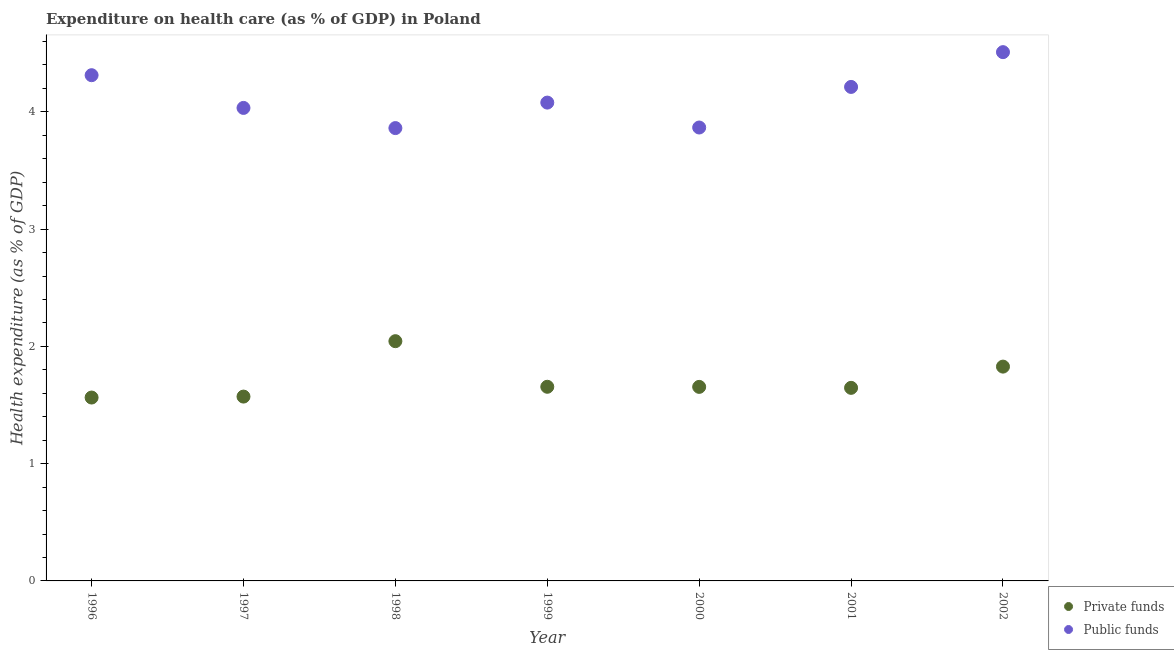Is the number of dotlines equal to the number of legend labels?
Offer a very short reply. Yes. What is the amount of private funds spent in healthcare in 2002?
Offer a terse response. 1.83. Across all years, what is the maximum amount of private funds spent in healthcare?
Provide a short and direct response. 2.04. Across all years, what is the minimum amount of private funds spent in healthcare?
Ensure brevity in your answer.  1.56. In which year was the amount of public funds spent in healthcare maximum?
Make the answer very short. 2002. In which year was the amount of private funds spent in healthcare minimum?
Give a very brief answer. 1996. What is the total amount of private funds spent in healthcare in the graph?
Provide a succinct answer. 11.96. What is the difference between the amount of public funds spent in healthcare in 1997 and that in 2001?
Provide a succinct answer. -0.18. What is the difference between the amount of private funds spent in healthcare in 1997 and the amount of public funds spent in healthcare in 1998?
Offer a very short reply. -2.29. What is the average amount of private funds spent in healthcare per year?
Your answer should be compact. 1.71. In the year 1999, what is the difference between the amount of private funds spent in healthcare and amount of public funds spent in healthcare?
Your answer should be compact. -2.42. In how many years, is the amount of private funds spent in healthcare greater than 1.4 %?
Offer a terse response. 7. What is the ratio of the amount of private funds spent in healthcare in 1997 to that in 2000?
Keep it short and to the point. 0.95. Is the difference between the amount of public funds spent in healthcare in 1997 and 2002 greater than the difference between the amount of private funds spent in healthcare in 1997 and 2002?
Make the answer very short. No. What is the difference between the highest and the second highest amount of private funds spent in healthcare?
Make the answer very short. 0.22. What is the difference between the highest and the lowest amount of public funds spent in healthcare?
Offer a very short reply. 0.65. In how many years, is the amount of public funds spent in healthcare greater than the average amount of public funds spent in healthcare taken over all years?
Your response must be concise. 3. Is the sum of the amount of public funds spent in healthcare in 1997 and 1999 greater than the maximum amount of private funds spent in healthcare across all years?
Your answer should be very brief. Yes. Is the amount of public funds spent in healthcare strictly greater than the amount of private funds spent in healthcare over the years?
Your response must be concise. Yes. How many dotlines are there?
Offer a terse response. 2. How many years are there in the graph?
Keep it short and to the point. 7. Does the graph contain any zero values?
Your answer should be compact. No. Does the graph contain grids?
Ensure brevity in your answer.  No. Where does the legend appear in the graph?
Your response must be concise. Bottom right. What is the title of the graph?
Offer a terse response. Expenditure on health care (as % of GDP) in Poland. Does "Investments" appear as one of the legend labels in the graph?
Provide a short and direct response. No. What is the label or title of the X-axis?
Provide a succinct answer. Year. What is the label or title of the Y-axis?
Keep it short and to the point. Health expenditure (as % of GDP). What is the Health expenditure (as % of GDP) in Private funds in 1996?
Your answer should be very brief. 1.56. What is the Health expenditure (as % of GDP) in Public funds in 1996?
Your response must be concise. 4.31. What is the Health expenditure (as % of GDP) in Private funds in 1997?
Your response must be concise. 1.57. What is the Health expenditure (as % of GDP) of Public funds in 1997?
Provide a short and direct response. 4.03. What is the Health expenditure (as % of GDP) in Private funds in 1998?
Offer a very short reply. 2.04. What is the Health expenditure (as % of GDP) of Public funds in 1998?
Give a very brief answer. 3.86. What is the Health expenditure (as % of GDP) of Private funds in 1999?
Ensure brevity in your answer.  1.66. What is the Health expenditure (as % of GDP) in Public funds in 1999?
Your answer should be very brief. 4.08. What is the Health expenditure (as % of GDP) of Private funds in 2000?
Your answer should be very brief. 1.65. What is the Health expenditure (as % of GDP) of Public funds in 2000?
Give a very brief answer. 3.87. What is the Health expenditure (as % of GDP) of Private funds in 2001?
Give a very brief answer. 1.65. What is the Health expenditure (as % of GDP) in Public funds in 2001?
Offer a very short reply. 4.21. What is the Health expenditure (as % of GDP) in Private funds in 2002?
Make the answer very short. 1.83. What is the Health expenditure (as % of GDP) in Public funds in 2002?
Keep it short and to the point. 4.51. Across all years, what is the maximum Health expenditure (as % of GDP) in Private funds?
Keep it short and to the point. 2.04. Across all years, what is the maximum Health expenditure (as % of GDP) in Public funds?
Make the answer very short. 4.51. Across all years, what is the minimum Health expenditure (as % of GDP) of Private funds?
Offer a very short reply. 1.56. Across all years, what is the minimum Health expenditure (as % of GDP) of Public funds?
Offer a very short reply. 3.86. What is the total Health expenditure (as % of GDP) of Private funds in the graph?
Your answer should be very brief. 11.96. What is the total Health expenditure (as % of GDP) in Public funds in the graph?
Ensure brevity in your answer.  28.87. What is the difference between the Health expenditure (as % of GDP) of Private funds in 1996 and that in 1997?
Ensure brevity in your answer.  -0.01. What is the difference between the Health expenditure (as % of GDP) in Public funds in 1996 and that in 1997?
Your answer should be compact. 0.28. What is the difference between the Health expenditure (as % of GDP) of Private funds in 1996 and that in 1998?
Keep it short and to the point. -0.48. What is the difference between the Health expenditure (as % of GDP) of Public funds in 1996 and that in 1998?
Provide a short and direct response. 0.45. What is the difference between the Health expenditure (as % of GDP) in Private funds in 1996 and that in 1999?
Your answer should be very brief. -0.09. What is the difference between the Health expenditure (as % of GDP) in Public funds in 1996 and that in 1999?
Your answer should be compact. 0.23. What is the difference between the Health expenditure (as % of GDP) of Private funds in 1996 and that in 2000?
Make the answer very short. -0.09. What is the difference between the Health expenditure (as % of GDP) in Public funds in 1996 and that in 2000?
Offer a terse response. 0.45. What is the difference between the Health expenditure (as % of GDP) of Private funds in 1996 and that in 2001?
Provide a succinct answer. -0.08. What is the difference between the Health expenditure (as % of GDP) in Private funds in 1996 and that in 2002?
Provide a succinct answer. -0.26. What is the difference between the Health expenditure (as % of GDP) in Public funds in 1996 and that in 2002?
Your response must be concise. -0.2. What is the difference between the Health expenditure (as % of GDP) in Private funds in 1997 and that in 1998?
Your answer should be very brief. -0.47. What is the difference between the Health expenditure (as % of GDP) in Public funds in 1997 and that in 1998?
Ensure brevity in your answer.  0.17. What is the difference between the Health expenditure (as % of GDP) of Private funds in 1997 and that in 1999?
Ensure brevity in your answer.  -0.08. What is the difference between the Health expenditure (as % of GDP) of Public funds in 1997 and that in 1999?
Provide a short and direct response. -0.05. What is the difference between the Health expenditure (as % of GDP) of Private funds in 1997 and that in 2000?
Keep it short and to the point. -0.08. What is the difference between the Health expenditure (as % of GDP) in Public funds in 1997 and that in 2000?
Make the answer very short. 0.17. What is the difference between the Health expenditure (as % of GDP) of Private funds in 1997 and that in 2001?
Provide a short and direct response. -0.07. What is the difference between the Health expenditure (as % of GDP) of Public funds in 1997 and that in 2001?
Provide a short and direct response. -0.18. What is the difference between the Health expenditure (as % of GDP) in Private funds in 1997 and that in 2002?
Make the answer very short. -0.26. What is the difference between the Health expenditure (as % of GDP) of Public funds in 1997 and that in 2002?
Your answer should be very brief. -0.48. What is the difference between the Health expenditure (as % of GDP) of Private funds in 1998 and that in 1999?
Your answer should be compact. 0.39. What is the difference between the Health expenditure (as % of GDP) in Public funds in 1998 and that in 1999?
Provide a short and direct response. -0.22. What is the difference between the Health expenditure (as % of GDP) in Private funds in 1998 and that in 2000?
Your response must be concise. 0.39. What is the difference between the Health expenditure (as % of GDP) of Public funds in 1998 and that in 2000?
Your answer should be very brief. -0. What is the difference between the Health expenditure (as % of GDP) of Private funds in 1998 and that in 2001?
Offer a terse response. 0.4. What is the difference between the Health expenditure (as % of GDP) in Public funds in 1998 and that in 2001?
Make the answer very short. -0.35. What is the difference between the Health expenditure (as % of GDP) of Private funds in 1998 and that in 2002?
Your answer should be very brief. 0.22. What is the difference between the Health expenditure (as % of GDP) in Public funds in 1998 and that in 2002?
Your response must be concise. -0.65. What is the difference between the Health expenditure (as % of GDP) of Private funds in 1999 and that in 2000?
Offer a very short reply. 0. What is the difference between the Health expenditure (as % of GDP) of Public funds in 1999 and that in 2000?
Your answer should be compact. 0.21. What is the difference between the Health expenditure (as % of GDP) in Private funds in 1999 and that in 2001?
Keep it short and to the point. 0.01. What is the difference between the Health expenditure (as % of GDP) of Public funds in 1999 and that in 2001?
Make the answer very short. -0.13. What is the difference between the Health expenditure (as % of GDP) of Private funds in 1999 and that in 2002?
Keep it short and to the point. -0.17. What is the difference between the Health expenditure (as % of GDP) in Public funds in 1999 and that in 2002?
Your answer should be very brief. -0.43. What is the difference between the Health expenditure (as % of GDP) of Private funds in 2000 and that in 2001?
Keep it short and to the point. 0.01. What is the difference between the Health expenditure (as % of GDP) in Public funds in 2000 and that in 2001?
Ensure brevity in your answer.  -0.35. What is the difference between the Health expenditure (as % of GDP) in Private funds in 2000 and that in 2002?
Offer a terse response. -0.17. What is the difference between the Health expenditure (as % of GDP) of Public funds in 2000 and that in 2002?
Your answer should be compact. -0.64. What is the difference between the Health expenditure (as % of GDP) in Private funds in 2001 and that in 2002?
Give a very brief answer. -0.18. What is the difference between the Health expenditure (as % of GDP) of Public funds in 2001 and that in 2002?
Offer a very short reply. -0.3. What is the difference between the Health expenditure (as % of GDP) in Private funds in 1996 and the Health expenditure (as % of GDP) in Public funds in 1997?
Your answer should be very brief. -2.47. What is the difference between the Health expenditure (as % of GDP) of Private funds in 1996 and the Health expenditure (as % of GDP) of Public funds in 1998?
Offer a terse response. -2.3. What is the difference between the Health expenditure (as % of GDP) in Private funds in 1996 and the Health expenditure (as % of GDP) in Public funds in 1999?
Your answer should be compact. -2.52. What is the difference between the Health expenditure (as % of GDP) in Private funds in 1996 and the Health expenditure (as % of GDP) in Public funds in 2000?
Your answer should be compact. -2.3. What is the difference between the Health expenditure (as % of GDP) of Private funds in 1996 and the Health expenditure (as % of GDP) of Public funds in 2001?
Provide a succinct answer. -2.65. What is the difference between the Health expenditure (as % of GDP) of Private funds in 1996 and the Health expenditure (as % of GDP) of Public funds in 2002?
Make the answer very short. -2.95. What is the difference between the Health expenditure (as % of GDP) of Private funds in 1997 and the Health expenditure (as % of GDP) of Public funds in 1998?
Your response must be concise. -2.29. What is the difference between the Health expenditure (as % of GDP) in Private funds in 1997 and the Health expenditure (as % of GDP) in Public funds in 1999?
Provide a short and direct response. -2.51. What is the difference between the Health expenditure (as % of GDP) of Private funds in 1997 and the Health expenditure (as % of GDP) of Public funds in 2000?
Provide a succinct answer. -2.29. What is the difference between the Health expenditure (as % of GDP) in Private funds in 1997 and the Health expenditure (as % of GDP) in Public funds in 2001?
Your answer should be very brief. -2.64. What is the difference between the Health expenditure (as % of GDP) in Private funds in 1997 and the Health expenditure (as % of GDP) in Public funds in 2002?
Provide a succinct answer. -2.94. What is the difference between the Health expenditure (as % of GDP) of Private funds in 1998 and the Health expenditure (as % of GDP) of Public funds in 1999?
Make the answer very short. -2.03. What is the difference between the Health expenditure (as % of GDP) in Private funds in 1998 and the Health expenditure (as % of GDP) in Public funds in 2000?
Make the answer very short. -1.82. What is the difference between the Health expenditure (as % of GDP) of Private funds in 1998 and the Health expenditure (as % of GDP) of Public funds in 2001?
Offer a terse response. -2.17. What is the difference between the Health expenditure (as % of GDP) in Private funds in 1998 and the Health expenditure (as % of GDP) in Public funds in 2002?
Your response must be concise. -2.46. What is the difference between the Health expenditure (as % of GDP) in Private funds in 1999 and the Health expenditure (as % of GDP) in Public funds in 2000?
Offer a very short reply. -2.21. What is the difference between the Health expenditure (as % of GDP) in Private funds in 1999 and the Health expenditure (as % of GDP) in Public funds in 2001?
Make the answer very short. -2.56. What is the difference between the Health expenditure (as % of GDP) in Private funds in 1999 and the Health expenditure (as % of GDP) in Public funds in 2002?
Give a very brief answer. -2.85. What is the difference between the Health expenditure (as % of GDP) of Private funds in 2000 and the Health expenditure (as % of GDP) of Public funds in 2001?
Provide a succinct answer. -2.56. What is the difference between the Health expenditure (as % of GDP) in Private funds in 2000 and the Health expenditure (as % of GDP) in Public funds in 2002?
Your answer should be compact. -2.85. What is the difference between the Health expenditure (as % of GDP) in Private funds in 2001 and the Health expenditure (as % of GDP) in Public funds in 2002?
Ensure brevity in your answer.  -2.86. What is the average Health expenditure (as % of GDP) in Private funds per year?
Keep it short and to the point. 1.71. What is the average Health expenditure (as % of GDP) of Public funds per year?
Give a very brief answer. 4.12. In the year 1996, what is the difference between the Health expenditure (as % of GDP) of Private funds and Health expenditure (as % of GDP) of Public funds?
Offer a terse response. -2.75. In the year 1997, what is the difference between the Health expenditure (as % of GDP) of Private funds and Health expenditure (as % of GDP) of Public funds?
Provide a succinct answer. -2.46. In the year 1998, what is the difference between the Health expenditure (as % of GDP) in Private funds and Health expenditure (as % of GDP) in Public funds?
Make the answer very short. -1.82. In the year 1999, what is the difference between the Health expenditure (as % of GDP) of Private funds and Health expenditure (as % of GDP) of Public funds?
Offer a terse response. -2.42. In the year 2000, what is the difference between the Health expenditure (as % of GDP) of Private funds and Health expenditure (as % of GDP) of Public funds?
Ensure brevity in your answer.  -2.21. In the year 2001, what is the difference between the Health expenditure (as % of GDP) of Private funds and Health expenditure (as % of GDP) of Public funds?
Your answer should be very brief. -2.57. In the year 2002, what is the difference between the Health expenditure (as % of GDP) in Private funds and Health expenditure (as % of GDP) in Public funds?
Your answer should be very brief. -2.68. What is the ratio of the Health expenditure (as % of GDP) of Public funds in 1996 to that in 1997?
Provide a succinct answer. 1.07. What is the ratio of the Health expenditure (as % of GDP) in Private funds in 1996 to that in 1998?
Offer a very short reply. 0.76. What is the ratio of the Health expenditure (as % of GDP) of Public funds in 1996 to that in 1998?
Offer a terse response. 1.12. What is the ratio of the Health expenditure (as % of GDP) in Private funds in 1996 to that in 1999?
Provide a short and direct response. 0.94. What is the ratio of the Health expenditure (as % of GDP) of Public funds in 1996 to that in 1999?
Offer a very short reply. 1.06. What is the ratio of the Health expenditure (as % of GDP) in Private funds in 1996 to that in 2000?
Keep it short and to the point. 0.95. What is the ratio of the Health expenditure (as % of GDP) of Public funds in 1996 to that in 2000?
Make the answer very short. 1.12. What is the ratio of the Health expenditure (as % of GDP) in Private funds in 1996 to that in 2001?
Provide a succinct answer. 0.95. What is the ratio of the Health expenditure (as % of GDP) in Public funds in 1996 to that in 2001?
Provide a short and direct response. 1.02. What is the ratio of the Health expenditure (as % of GDP) of Private funds in 1996 to that in 2002?
Offer a terse response. 0.86. What is the ratio of the Health expenditure (as % of GDP) of Public funds in 1996 to that in 2002?
Ensure brevity in your answer.  0.96. What is the ratio of the Health expenditure (as % of GDP) of Private funds in 1997 to that in 1998?
Make the answer very short. 0.77. What is the ratio of the Health expenditure (as % of GDP) of Public funds in 1997 to that in 1998?
Ensure brevity in your answer.  1.04. What is the ratio of the Health expenditure (as % of GDP) of Private funds in 1997 to that in 1999?
Your response must be concise. 0.95. What is the ratio of the Health expenditure (as % of GDP) of Public funds in 1997 to that in 1999?
Your response must be concise. 0.99. What is the ratio of the Health expenditure (as % of GDP) of Public funds in 1997 to that in 2000?
Your response must be concise. 1.04. What is the ratio of the Health expenditure (as % of GDP) in Private funds in 1997 to that in 2001?
Offer a very short reply. 0.95. What is the ratio of the Health expenditure (as % of GDP) of Public funds in 1997 to that in 2001?
Your answer should be compact. 0.96. What is the ratio of the Health expenditure (as % of GDP) of Private funds in 1997 to that in 2002?
Your answer should be compact. 0.86. What is the ratio of the Health expenditure (as % of GDP) of Public funds in 1997 to that in 2002?
Ensure brevity in your answer.  0.89. What is the ratio of the Health expenditure (as % of GDP) in Private funds in 1998 to that in 1999?
Provide a short and direct response. 1.23. What is the ratio of the Health expenditure (as % of GDP) in Public funds in 1998 to that in 1999?
Your answer should be very brief. 0.95. What is the ratio of the Health expenditure (as % of GDP) of Private funds in 1998 to that in 2000?
Ensure brevity in your answer.  1.24. What is the ratio of the Health expenditure (as % of GDP) in Public funds in 1998 to that in 2000?
Provide a succinct answer. 1. What is the ratio of the Health expenditure (as % of GDP) of Private funds in 1998 to that in 2001?
Provide a succinct answer. 1.24. What is the ratio of the Health expenditure (as % of GDP) in Private funds in 1998 to that in 2002?
Your answer should be very brief. 1.12. What is the ratio of the Health expenditure (as % of GDP) of Public funds in 1998 to that in 2002?
Offer a very short reply. 0.86. What is the ratio of the Health expenditure (as % of GDP) of Private funds in 1999 to that in 2000?
Provide a succinct answer. 1. What is the ratio of the Health expenditure (as % of GDP) of Public funds in 1999 to that in 2000?
Your answer should be compact. 1.05. What is the ratio of the Health expenditure (as % of GDP) of Public funds in 1999 to that in 2001?
Make the answer very short. 0.97. What is the ratio of the Health expenditure (as % of GDP) of Private funds in 1999 to that in 2002?
Offer a terse response. 0.91. What is the ratio of the Health expenditure (as % of GDP) of Public funds in 1999 to that in 2002?
Offer a terse response. 0.9. What is the ratio of the Health expenditure (as % of GDP) in Public funds in 2000 to that in 2001?
Your answer should be compact. 0.92. What is the ratio of the Health expenditure (as % of GDP) of Private funds in 2000 to that in 2002?
Keep it short and to the point. 0.91. What is the ratio of the Health expenditure (as % of GDP) in Public funds in 2000 to that in 2002?
Provide a short and direct response. 0.86. What is the ratio of the Health expenditure (as % of GDP) of Private funds in 2001 to that in 2002?
Give a very brief answer. 0.9. What is the ratio of the Health expenditure (as % of GDP) in Public funds in 2001 to that in 2002?
Offer a terse response. 0.93. What is the difference between the highest and the second highest Health expenditure (as % of GDP) in Private funds?
Give a very brief answer. 0.22. What is the difference between the highest and the second highest Health expenditure (as % of GDP) of Public funds?
Keep it short and to the point. 0.2. What is the difference between the highest and the lowest Health expenditure (as % of GDP) of Private funds?
Make the answer very short. 0.48. What is the difference between the highest and the lowest Health expenditure (as % of GDP) in Public funds?
Your answer should be very brief. 0.65. 